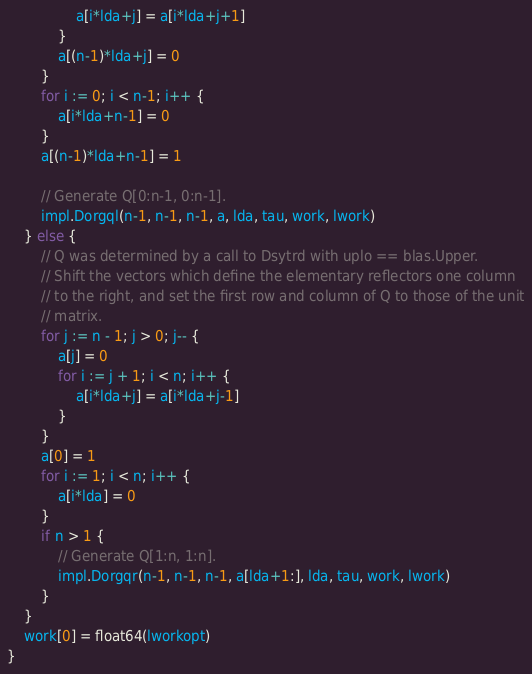<code> <loc_0><loc_0><loc_500><loc_500><_Go_>				a[i*lda+j] = a[i*lda+j+1]
			}
			a[(n-1)*lda+j] = 0
		}
		for i := 0; i < n-1; i++ {
			a[i*lda+n-1] = 0
		}
		a[(n-1)*lda+n-1] = 1

		// Generate Q[0:n-1, 0:n-1].
		impl.Dorgql(n-1, n-1, n-1, a, lda, tau, work, lwork)
	} else {
		// Q was determined by a call to Dsytrd with uplo == blas.Upper.
		// Shift the vectors which define the elementary reflectors one column
		// to the right, and set the first row and column of Q to those of the unit
		// matrix.
		for j := n - 1; j > 0; j-- {
			a[j] = 0
			for i := j + 1; i < n; i++ {
				a[i*lda+j] = a[i*lda+j-1]
			}
		}
		a[0] = 1
		for i := 1; i < n; i++ {
			a[i*lda] = 0
		}
		if n > 1 {
			// Generate Q[1:n, 1:n].
			impl.Dorgqr(n-1, n-1, n-1, a[lda+1:], lda, tau, work, lwork)
		}
	}
	work[0] = float64(lworkopt)
}
</code> 